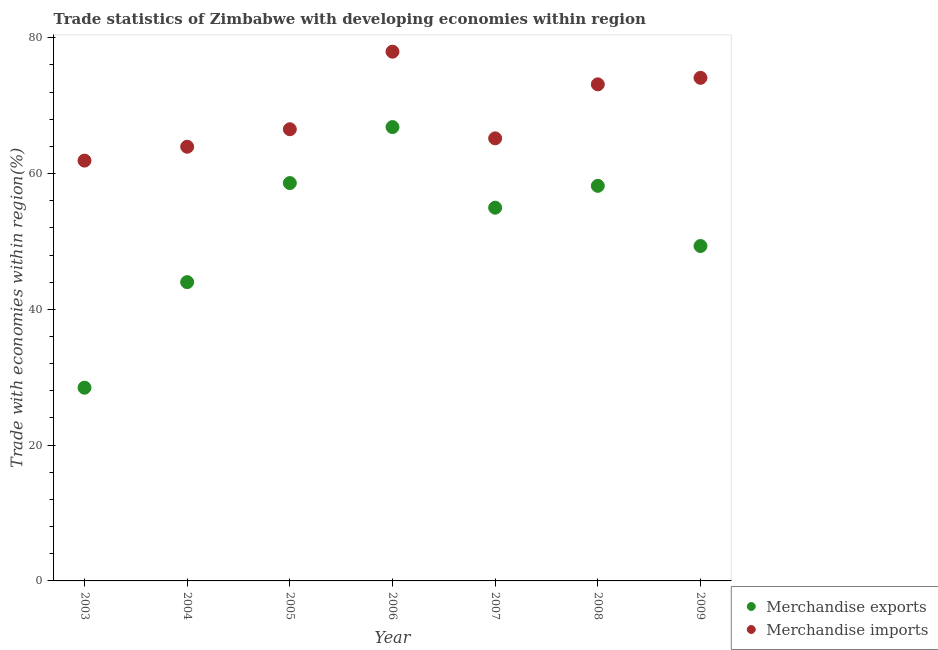What is the merchandise exports in 2008?
Provide a short and direct response. 58.2. Across all years, what is the maximum merchandise imports?
Make the answer very short. 77.96. Across all years, what is the minimum merchandise imports?
Keep it short and to the point. 61.91. In which year was the merchandise imports minimum?
Provide a short and direct response. 2003. What is the total merchandise imports in the graph?
Offer a terse response. 482.79. What is the difference between the merchandise exports in 2004 and that in 2006?
Offer a very short reply. -22.84. What is the difference between the merchandise imports in 2003 and the merchandise exports in 2005?
Your answer should be very brief. 3.31. What is the average merchandise exports per year?
Ensure brevity in your answer.  51.49. In the year 2004, what is the difference between the merchandise exports and merchandise imports?
Your response must be concise. -19.94. In how many years, is the merchandise exports greater than 48 %?
Make the answer very short. 5. What is the ratio of the merchandise exports in 2003 to that in 2008?
Provide a short and direct response. 0.49. Is the difference between the merchandise exports in 2005 and 2008 greater than the difference between the merchandise imports in 2005 and 2008?
Give a very brief answer. Yes. What is the difference between the highest and the second highest merchandise imports?
Offer a very short reply. 3.85. What is the difference between the highest and the lowest merchandise imports?
Keep it short and to the point. 16.05. In how many years, is the merchandise exports greater than the average merchandise exports taken over all years?
Your answer should be compact. 4. Does the merchandise exports monotonically increase over the years?
Your answer should be compact. No. Is the merchandise imports strictly greater than the merchandise exports over the years?
Your answer should be very brief. Yes. Is the merchandise exports strictly less than the merchandise imports over the years?
Your answer should be compact. Yes. Are the values on the major ticks of Y-axis written in scientific E-notation?
Provide a succinct answer. No. Does the graph contain grids?
Keep it short and to the point. No. Where does the legend appear in the graph?
Offer a very short reply. Bottom right. How are the legend labels stacked?
Your answer should be compact. Vertical. What is the title of the graph?
Offer a terse response. Trade statistics of Zimbabwe with developing economies within region. What is the label or title of the Y-axis?
Your response must be concise. Trade with economies within region(%). What is the Trade with economies within region(%) of Merchandise exports in 2003?
Provide a short and direct response. 28.46. What is the Trade with economies within region(%) in Merchandise imports in 2003?
Provide a short and direct response. 61.91. What is the Trade with economies within region(%) in Merchandise exports in 2004?
Ensure brevity in your answer.  44.01. What is the Trade with economies within region(%) of Merchandise imports in 2004?
Your answer should be compact. 63.96. What is the Trade with economies within region(%) of Merchandise exports in 2005?
Your answer should be compact. 58.61. What is the Trade with economies within region(%) of Merchandise imports in 2005?
Offer a terse response. 66.53. What is the Trade with economies within region(%) in Merchandise exports in 2006?
Provide a short and direct response. 66.85. What is the Trade with economies within region(%) in Merchandise imports in 2006?
Ensure brevity in your answer.  77.96. What is the Trade with economies within region(%) in Merchandise exports in 2007?
Ensure brevity in your answer.  54.97. What is the Trade with economies within region(%) in Merchandise imports in 2007?
Your response must be concise. 65.19. What is the Trade with economies within region(%) of Merchandise exports in 2008?
Give a very brief answer. 58.2. What is the Trade with economies within region(%) of Merchandise imports in 2008?
Your answer should be compact. 73.14. What is the Trade with economies within region(%) of Merchandise exports in 2009?
Your answer should be compact. 49.33. What is the Trade with economies within region(%) of Merchandise imports in 2009?
Ensure brevity in your answer.  74.1. Across all years, what is the maximum Trade with economies within region(%) in Merchandise exports?
Your answer should be very brief. 66.85. Across all years, what is the maximum Trade with economies within region(%) in Merchandise imports?
Your answer should be very brief. 77.96. Across all years, what is the minimum Trade with economies within region(%) in Merchandise exports?
Give a very brief answer. 28.46. Across all years, what is the minimum Trade with economies within region(%) of Merchandise imports?
Provide a succinct answer. 61.91. What is the total Trade with economies within region(%) in Merchandise exports in the graph?
Make the answer very short. 360.43. What is the total Trade with economies within region(%) of Merchandise imports in the graph?
Make the answer very short. 482.79. What is the difference between the Trade with economies within region(%) of Merchandise exports in 2003 and that in 2004?
Provide a short and direct response. -15.55. What is the difference between the Trade with economies within region(%) of Merchandise imports in 2003 and that in 2004?
Make the answer very short. -2.04. What is the difference between the Trade with economies within region(%) in Merchandise exports in 2003 and that in 2005?
Provide a short and direct response. -30.15. What is the difference between the Trade with economies within region(%) in Merchandise imports in 2003 and that in 2005?
Keep it short and to the point. -4.62. What is the difference between the Trade with economies within region(%) of Merchandise exports in 2003 and that in 2006?
Give a very brief answer. -38.39. What is the difference between the Trade with economies within region(%) of Merchandise imports in 2003 and that in 2006?
Your answer should be very brief. -16.05. What is the difference between the Trade with economies within region(%) of Merchandise exports in 2003 and that in 2007?
Your response must be concise. -26.51. What is the difference between the Trade with economies within region(%) of Merchandise imports in 2003 and that in 2007?
Your answer should be very brief. -3.28. What is the difference between the Trade with economies within region(%) of Merchandise exports in 2003 and that in 2008?
Give a very brief answer. -29.73. What is the difference between the Trade with economies within region(%) in Merchandise imports in 2003 and that in 2008?
Your answer should be compact. -11.23. What is the difference between the Trade with economies within region(%) in Merchandise exports in 2003 and that in 2009?
Provide a short and direct response. -20.87. What is the difference between the Trade with economies within region(%) in Merchandise imports in 2003 and that in 2009?
Your answer should be very brief. -12.19. What is the difference between the Trade with economies within region(%) of Merchandise exports in 2004 and that in 2005?
Your answer should be compact. -14.59. What is the difference between the Trade with economies within region(%) in Merchandise imports in 2004 and that in 2005?
Offer a very short reply. -2.58. What is the difference between the Trade with economies within region(%) in Merchandise exports in 2004 and that in 2006?
Ensure brevity in your answer.  -22.84. What is the difference between the Trade with economies within region(%) of Merchandise imports in 2004 and that in 2006?
Offer a very short reply. -14. What is the difference between the Trade with economies within region(%) in Merchandise exports in 2004 and that in 2007?
Keep it short and to the point. -10.96. What is the difference between the Trade with economies within region(%) in Merchandise imports in 2004 and that in 2007?
Your answer should be compact. -1.23. What is the difference between the Trade with economies within region(%) of Merchandise exports in 2004 and that in 2008?
Give a very brief answer. -14.18. What is the difference between the Trade with economies within region(%) in Merchandise imports in 2004 and that in 2008?
Your answer should be very brief. -9.19. What is the difference between the Trade with economies within region(%) of Merchandise exports in 2004 and that in 2009?
Offer a terse response. -5.32. What is the difference between the Trade with economies within region(%) of Merchandise imports in 2004 and that in 2009?
Offer a very short reply. -10.15. What is the difference between the Trade with economies within region(%) of Merchandise exports in 2005 and that in 2006?
Your answer should be compact. -8.25. What is the difference between the Trade with economies within region(%) of Merchandise imports in 2005 and that in 2006?
Provide a short and direct response. -11.43. What is the difference between the Trade with economies within region(%) in Merchandise exports in 2005 and that in 2007?
Provide a short and direct response. 3.63. What is the difference between the Trade with economies within region(%) in Merchandise imports in 2005 and that in 2007?
Your answer should be compact. 1.34. What is the difference between the Trade with economies within region(%) of Merchandise exports in 2005 and that in 2008?
Your response must be concise. 0.41. What is the difference between the Trade with economies within region(%) of Merchandise imports in 2005 and that in 2008?
Provide a succinct answer. -6.61. What is the difference between the Trade with economies within region(%) of Merchandise exports in 2005 and that in 2009?
Make the answer very short. 9.28. What is the difference between the Trade with economies within region(%) in Merchandise imports in 2005 and that in 2009?
Give a very brief answer. -7.57. What is the difference between the Trade with economies within region(%) of Merchandise exports in 2006 and that in 2007?
Your answer should be very brief. 11.88. What is the difference between the Trade with economies within region(%) in Merchandise imports in 2006 and that in 2007?
Provide a succinct answer. 12.77. What is the difference between the Trade with economies within region(%) of Merchandise exports in 2006 and that in 2008?
Make the answer very short. 8.66. What is the difference between the Trade with economies within region(%) in Merchandise imports in 2006 and that in 2008?
Provide a succinct answer. 4.81. What is the difference between the Trade with economies within region(%) of Merchandise exports in 2006 and that in 2009?
Offer a very short reply. 17.52. What is the difference between the Trade with economies within region(%) of Merchandise imports in 2006 and that in 2009?
Offer a terse response. 3.85. What is the difference between the Trade with economies within region(%) in Merchandise exports in 2007 and that in 2008?
Provide a succinct answer. -3.22. What is the difference between the Trade with economies within region(%) in Merchandise imports in 2007 and that in 2008?
Make the answer very short. -7.96. What is the difference between the Trade with economies within region(%) of Merchandise exports in 2007 and that in 2009?
Make the answer very short. 5.64. What is the difference between the Trade with economies within region(%) of Merchandise imports in 2007 and that in 2009?
Keep it short and to the point. -8.91. What is the difference between the Trade with economies within region(%) in Merchandise exports in 2008 and that in 2009?
Offer a very short reply. 8.86. What is the difference between the Trade with economies within region(%) of Merchandise imports in 2008 and that in 2009?
Provide a short and direct response. -0.96. What is the difference between the Trade with economies within region(%) in Merchandise exports in 2003 and the Trade with economies within region(%) in Merchandise imports in 2004?
Offer a very short reply. -35.5. What is the difference between the Trade with economies within region(%) of Merchandise exports in 2003 and the Trade with economies within region(%) of Merchandise imports in 2005?
Keep it short and to the point. -38.07. What is the difference between the Trade with economies within region(%) in Merchandise exports in 2003 and the Trade with economies within region(%) in Merchandise imports in 2006?
Your response must be concise. -49.5. What is the difference between the Trade with economies within region(%) of Merchandise exports in 2003 and the Trade with economies within region(%) of Merchandise imports in 2007?
Offer a very short reply. -36.73. What is the difference between the Trade with economies within region(%) in Merchandise exports in 2003 and the Trade with economies within region(%) in Merchandise imports in 2008?
Your answer should be compact. -44.68. What is the difference between the Trade with economies within region(%) in Merchandise exports in 2003 and the Trade with economies within region(%) in Merchandise imports in 2009?
Provide a short and direct response. -45.64. What is the difference between the Trade with economies within region(%) of Merchandise exports in 2004 and the Trade with economies within region(%) of Merchandise imports in 2005?
Your answer should be very brief. -22.52. What is the difference between the Trade with economies within region(%) of Merchandise exports in 2004 and the Trade with economies within region(%) of Merchandise imports in 2006?
Offer a terse response. -33.94. What is the difference between the Trade with economies within region(%) in Merchandise exports in 2004 and the Trade with economies within region(%) in Merchandise imports in 2007?
Offer a terse response. -21.18. What is the difference between the Trade with economies within region(%) in Merchandise exports in 2004 and the Trade with economies within region(%) in Merchandise imports in 2008?
Keep it short and to the point. -29.13. What is the difference between the Trade with economies within region(%) in Merchandise exports in 2004 and the Trade with economies within region(%) in Merchandise imports in 2009?
Your answer should be very brief. -30.09. What is the difference between the Trade with economies within region(%) in Merchandise exports in 2005 and the Trade with economies within region(%) in Merchandise imports in 2006?
Provide a short and direct response. -19.35. What is the difference between the Trade with economies within region(%) of Merchandise exports in 2005 and the Trade with economies within region(%) of Merchandise imports in 2007?
Your answer should be compact. -6.58. What is the difference between the Trade with economies within region(%) in Merchandise exports in 2005 and the Trade with economies within region(%) in Merchandise imports in 2008?
Your answer should be compact. -14.54. What is the difference between the Trade with economies within region(%) of Merchandise exports in 2005 and the Trade with economies within region(%) of Merchandise imports in 2009?
Make the answer very short. -15.5. What is the difference between the Trade with economies within region(%) of Merchandise exports in 2006 and the Trade with economies within region(%) of Merchandise imports in 2007?
Keep it short and to the point. 1.66. What is the difference between the Trade with economies within region(%) in Merchandise exports in 2006 and the Trade with economies within region(%) in Merchandise imports in 2008?
Your answer should be very brief. -6.29. What is the difference between the Trade with economies within region(%) of Merchandise exports in 2006 and the Trade with economies within region(%) of Merchandise imports in 2009?
Provide a short and direct response. -7.25. What is the difference between the Trade with economies within region(%) of Merchandise exports in 2007 and the Trade with economies within region(%) of Merchandise imports in 2008?
Ensure brevity in your answer.  -18.17. What is the difference between the Trade with economies within region(%) in Merchandise exports in 2007 and the Trade with economies within region(%) in Merchandise imports in 2009?
Offer a terse response. -19.13. What is the difference between the Trade with economies within region(%) of Merchandise exports in 2008 and the Trade with economies within region(%) of Merchandise imports in 2009?
Offer a terse response. -15.91. What is the average Trade with economies within region(%) in Merchandise exports per year?
Your response must be concise. 51.49. What is the average Trade with economies within region(%) in Merchandise imports per year?
Give a very brief answer. 68.97. In the year 2003, what is the difference between the Trade with economies within region(%) of Merchandise exports and Trade with economies within region(%) of Merchandise imports?
Your answer should be compact. -33.45. In the year 2004, what is the difference between the Trade with economies within region(%) in Merchandise exports and Trade with economies within region(%) in Merchandise imports?
Offer a terse response. -19.94. In the year 2005, what is the difference between the Trade with economies within region(%) of Merchandise exports and Trade with economies within region(%) of Merchandise imports?
Give a very brief answer. -7.93. In the year 2006, what is the difference between the Trade with economies within region(%) in Merchandise exports and Trade with economies within region(%) in Merchandise imports?
Offer a terse response. -11.11. In the year 2007, what is the difference between the Trade with economies within region(%) in Merchandise exports and Trade with economies within region(%) in Merchandise imports?
Offer a terse response. -10.21. In the year 2008, what is the difference between the Trade with economies within region(%) in Merchandise exports and Trade with economies within region(%) in Merchandise imports?
Your answer should be very brief. -14.95. In the year 2009, what is the difference between the Trade with economies within region(%) of Merchandise exports and Trade with economies within region(%) of Merchandise imports?
Your response must be concise. -24.77. What is the ratio of the Trade with economies within region(%) in Merchandise exports in 2003 to that in 2004?
Your answer should be compact. 0.65. What is the ratio of the Trade with economies within region(%) in Merchandise exports in 2003 to that in 2005?
Your response must be concise. 0.49. What is the ratio of the Trade with economies within region(%) in Merchandise imports in 2003 to that in 2005?
Provide a short and direct response. 0.93. What is the ratio of the Trade with economies within region(%) in Merchandise exports in 2003 to that in 2006?
Your answer should be very brief. 0.43. What is the ratio of the Trade with economies within region(%) in Merchandise imports in 2003 to that in 2006?
Keep it short and to the point. 0.79. What is the ratio of the Trade with economies within region(%) of Merchandise exports in 2003 to that in 2007?
Your answer should be compact. 0.52. What is the ratio of the Trade with economies within region(%) in Merchandise imports in 2003 to that in 2007?
Provide a succinct answer. 0.95. What is the ratio of the Trade with economies within region(%) of Merchandise exports in 2003 to that in 2008?
Make the answer very short. 0.49. What is the ratio of the Trade with economies within region(%) in Merchandise imports in 2003 to that in 2008?
Make the answer very short. 0.85. What is the ratio of the Trade with economies within region(%) of Merchandise exports in 2003 to that in 2009?
Provide a short and direct response. 0.58. What is the ratio of the Trade with economies within region(%) in Merchandise imports in 2003 to that in 2009?
Your response must be concise. 0.84. What is the ratio of the Trade with economies within region(%) of Merchandise exports in 2004 to that in 2005?
Give a very brief answer. 0.75. What is the ratio of the Trade with economies within region(%) in Merchandise imports in 2004 to that in 2005?
Offer a terse response. 0.96. What is the ratio of the Trade with economies within region(%) of Merchandise exports in 2004 to that in 2006?
Offer a terse response. 0.66. What is the ratio of the Trade with economies within region(%) of Merchandise imports in 2004 to that in 2006?
Provide a succinct answer. 0.82. What is the ratio of the Trade with economies within region(%) of Merchandise exports in 2004 to that in 2007?
Give a very brief answer. 0.8. What is the ratio of the Trade with economies within region(%) of Merchandise imports in 2004 to that in 2007?
Provide a short and direct response. 0.98. What is the ratio of the Trade with economies within region(%) in Merchandise exports in 2004 to that in 2008?
Your answer should be compact. 0.76. What is the ratio of the Trade with economies within region(%) in Merchandise imports in 2004 to that in 2008?
Ensure brevity in your answer.  0.87. What is the ratio of the Trade with economies within region(%) in Merchandise exports in 2004 to that in 2009?
Offer a terse response. 0.89. What is the ratio of the Trade with economies within region(%) of Merchandise imports in 2004 to that in 2009?
Provide a succinct answer. 0.86. What is the ratio of the Trade with economies within region(%) of Merchandise exports in 2005 to that in 2006?
Provide a succinct answer. 0.88. What is the ratio of the Trade with economies within region(%) of Merchandise imports in 2005 to that in 2006?
Your answer should be compact. 0.85. What is the ratio of the Trade with economies within region(%) of Merchandise exports in 2005 to that in 2007?
Offer a very short reply. 1.07. What is the ratio of the Trade with economies within region(%) of Merchandise imports in 2005 to that in 2007?
Give a very brief answer. 1.02. What is the ratio of the Trade with economies within region(%) in Merchandise exports in 2005 to that in 2008?
Ensure brevity in your answer.  1.01. What is the ratio of the Trade with economies within region(%) in Merchandise imports in 2005 to that in 2008?
Make the answer very short. 0.91. What is the ratio of the Trade with economies within region(%) in Merchandise exports in 2005 to that in 2009?
Offer a terse response. 1.19. What is the ratio of the Trade with economies within region(%) of Merchandise imports in 2005 to that in 2009?
Give a very brief answer. 0.9. What is the ratio of the Trade with economies within region(%) of Merchandise exports in 2006 to that in 2007?
Offer a very short reply. 1.22. What is the ratio of the Trade with economies within region(%) of Merchandise imports in 2006 to that in 2007?
Offer a terse response. 1.2. What is the ratio of the Trade with economies within region(%) in Merchandise exports in 2006 to that in 2008?
Make the answer very short. 1.15. What is the ratio of the Trade with economies within region(%) of Merchandise imports in 2006 to that in 2008?
Your answer should be compact. 1.07. What is the ratio of the Trade with economies within region(%) in Merchandise exports in 2006 to that in 2009?
Provide a short and direct response. 1.36. What is the ratio of the Trade with economies within region(%) of Merchandise imports in 2006 to that in 2009?
Keep it short and to the point. 1.05. What is the ratio of the Trade with economies within region(%) in Merchandise exports in 2007 to that in 2008?
Offer a terse response. 0.94. What is the ratio of the Trade with economies within region(%) in Merchandise imports in 2007 to that in 2008?
Give a very brief answer. 0.89. What is the ratio of the Trade with economies within region(%) of Merchandise exports in 2007 to that in 2009?
Your answer should be compact. 1.11. What is the ratio of the Trade with economies within region(%) of Merchandise imports in 2007 to that in 2009?
Provide a succinct answer. 0.88. What is the ratio of the Trade with economies within region(%) in Merchandise exports in 2008 to that in 2009?
Your response must be concise. 1.18. What is the ratio of the Trade with economies within region(%) in Merchandise imports in 2008 to that in 2009?
Your answer should be compact. 0.99. What is the difference between the highest and the second highest Trade with economies within region(%) in Merchandise exports?
Give a very brief answer. 8.25. What is the difference between the highest and the second highest Trade with economies within region(%) of Merchandise imports?
Provide a short and direct response. 3.85. What is the difference between the highest and the lowest Trade with economies within region(%) in Merchandise exports?
Your answer should be very brief. 38.39. What is the difference between the highest and the lowest Trade with economies within region(%) in Merchandise imports?
Offer a terse response. 16.05. 